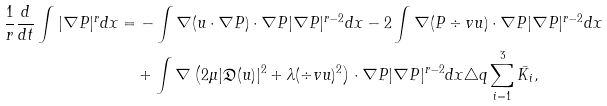<formula> <loc_0><loc_0><loc_500><loc_500>\frac { 1 } { r } \frac { d } { d t } \int | \nabla P | ^ { r } d x & = - \int \nabla ( u \cdot \nabla P ) \cdot \nabla P | \nabla P | ^ { r - 2 } d x - 2 \int \nabla ( P \div v u ) \cdot \nabla P | \nabla P | ^ { r - 2 } d x \\ & \quad + \int \nabla \left ( 2 \mu | \mathfrak { D } ( u ) | ^ { 2 } + \lambda ( \div v u ) ^ { 2 } \right ) \cdot \nabla P | \nabla P | ^ { r - 2 } d x \triangle q \sum _ { i = 1 } ^ { 3 } \bar { K _ { i } } ,</formula> 